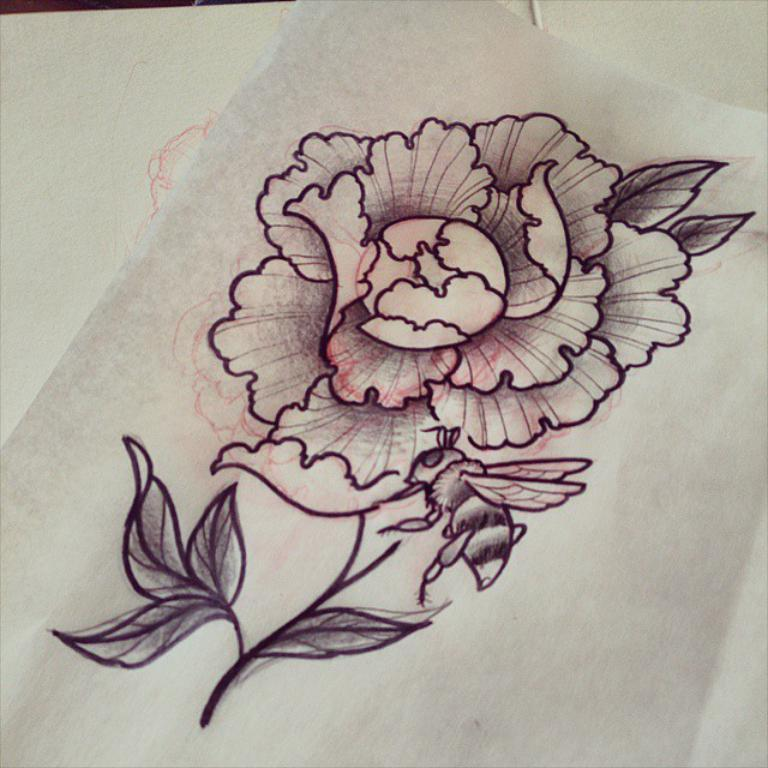What type of art is depicted in the image? There is a sketch art in the image. What is the subject of the sketch art? The sketch art is on a flower. What joke is being told in the image? There is no joke being told in the image; it features a sketch art of a flower. What discovery was made in the downtown area that is depicted in the image? There is no downtown area or discovery mentioned in the image; it only features a sketch art of a flower. 